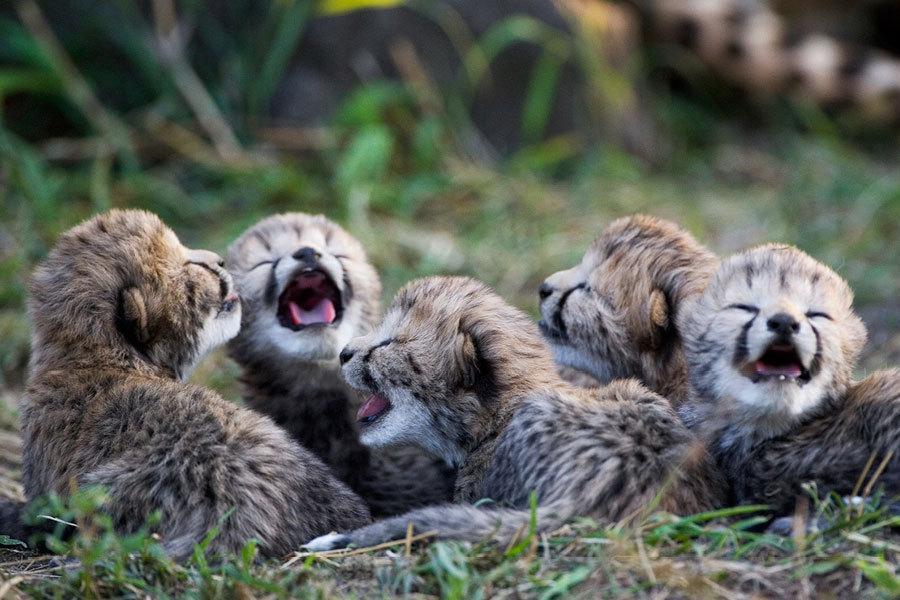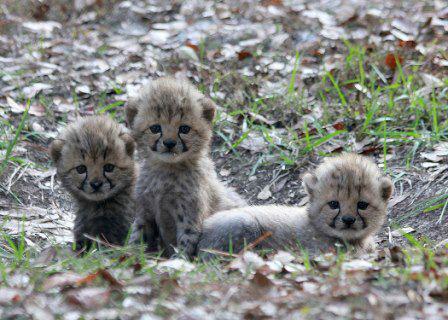The first image is the image on the left, the second image is the image on the right. Assess this claim about the two images: "A cub is shown hugging another leopard.". Correct or not? Answer yes or no. No. The first image is the image on the left, the second image is the image on the right. Analyze the images presented: Is the assertion "A cheetah kitten is draping one front paw over part of another cheetah and has its head above the other cheetah." valid? Answer yes or no. No. 